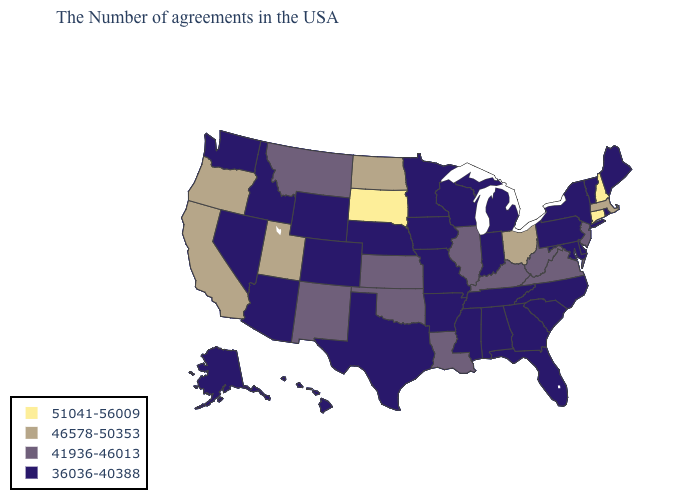What is the highest value in the Northeast ?
Concise answer only. 51041-56009. Among the states that border Texas , which have the highest value?
Give a very brief answer. Louisiana, Oklahoma, New Mexico. What is the value of Alabama?
Write a very short answer. 36036-40388. Name the states that have a value in the range 36036-40388?
Give a very brief answer. Maine, Rhode Island, Vermont, New York, Delaware, Maryland, Pennsylvania, North Carolina, South Carolina, Florida, Georgia, Michigan, Indiana, Alabama, Tennessee, Wisconsin, Mississippi, Missouri, Arkansas, Minnesota, Iowa, Nebraska, Texas, Wyoming, Colorado, Arizona, Idaho, Nevada, Washington, Alaska, Hawaii. Does Louisiana have the highest value in the USA?
Give a very brief answer. No. What is the value of Connecticut?
Answer briefly. 51041-56009. Name the states that have a value in the range 51041-56009?
Answer briefly. New Hampshire, Connecticut, South Dakota. How many symbols are there in the legend?
Answer briefly. 4. Does South Dakota have the highest value in the USA?
Write a very short answer. Yes. What is the value of New Hampshire?
Short answer required. 51041-56009. How many symbols are there in the legend?
Quick response, please. 4. Name the states that have a value in the range 51041-56009?
Write a very short answer. New Hampshire, Connecticut, South Dakota. Name the states that have a value in the range 46578-50353?
Short answer required. Massachusetts, Ohio, North Dakota, Utah, California, Oregon. What is the value of Minnesota?
Keep it brief. 36036-40388. 